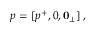<formula> <loc_0><loc_0><loc_500><loc_500>p = [ p ^ { + } , 0 , 0 _ { \perp } ] \, ,</formula> 